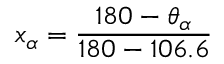<formula> <loc_0><loc_0><loc_500><loc_500>x _ { \alpha } = \frac { 1 8 0 - \theta _ { \alpha } } { 1 8 0 - 1 0 6 . 6 }</formula> 